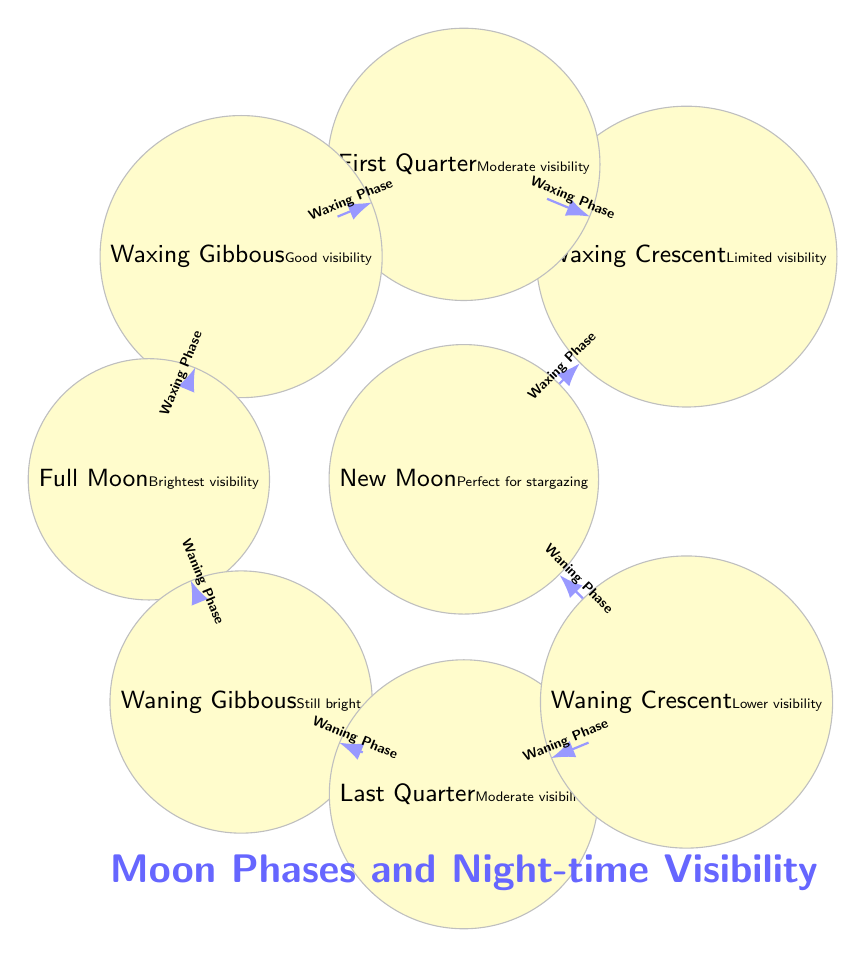What is the visibility during the Full Moon phase? The diagram states that during the Full Moon phase, the visibility is described as "Brightest visibility." This information is specifically noted next to the Full Moon node in the diagram.
Answer: Brightest visibility How many phases are indicated in the diagram? The diagram contains eight distinct phases of the Moon. By counting each moon node from New Moon to Waning Crescent, we see there are eight phases portrayed.
Answer: Eight What is the transition from the New Moon phase? The arrow leading from the New Moon phase points to the Waxing Crescent phase, indicating the first transition after a New Moon occurs to a Waxing Crescent. This relationship is directly represented in the diagram.
Answer: Waxing Crescent What is the phase before the Last Quarter? The diagram shows that the phase before the Last Quarter is the Waning Gibbous phase, as the arrow transitions from Waning Gibbous to Last Quarter. This direct connection is evident in the flow of the diagram.
Answer: Waning Gibbous Which phase indicates "Still bright" visibility? According to the diagram, the Waning Gibbous phase is associated with the description "Still bright," as stated next to that specific moon phase in the diagram.
Answer: Waning Gibbous During which phase is stargazing considered perfect? The diagram specifies that during the New Moon phase, it is ideal for stargazing, directly noting this phrase next to the New Moon in the diagram.
Answer: New Moon How does visibility change from Waxing Gibbous to Full Moon? The visibility improves from "Good visibility" during the Waxing Gibbous phase to "Brightest visibility" in the Full Moon phase. The diagram directly illustrates this progression, showing an increase in visibility.
Answer: Improves to Brightest visibility Which two phases have "Moderate visibility"? The diagram identifies both the First Quarter and Last Quarter phases as having "Moderate visibility." This information can be found next to each of these two phases in the diagram.
Answer: First Quarter and Last Quarter 